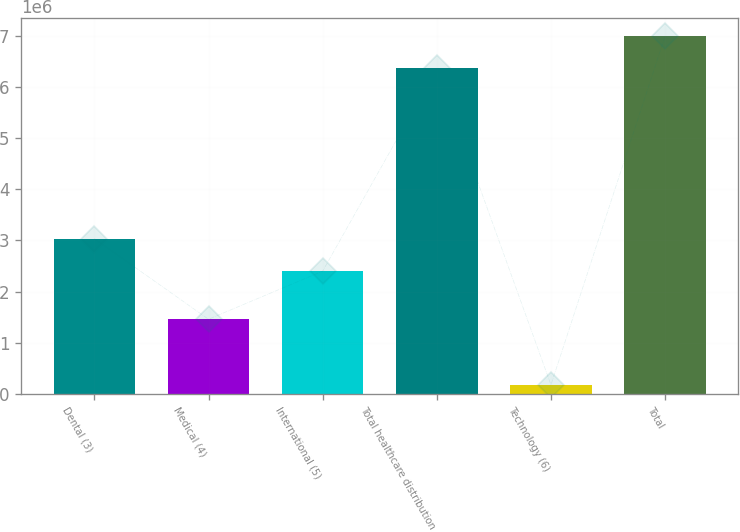<chart> <loc_0><loc_0><loc_500><loc_500><bar_chart><fcel>Dental (3)<fcel>Medical (4)<fcel>International (5)<fcel>Total healthcare distribution<fcel>Technology (6)<fcel>Total<nl><fcel>3.03462e+06<fcel>1.4571e+06<fcel>2.3981e+06<fcel>6.36513e+06<fcel>173208<fcel>7.00164e+06<nl></chart> 